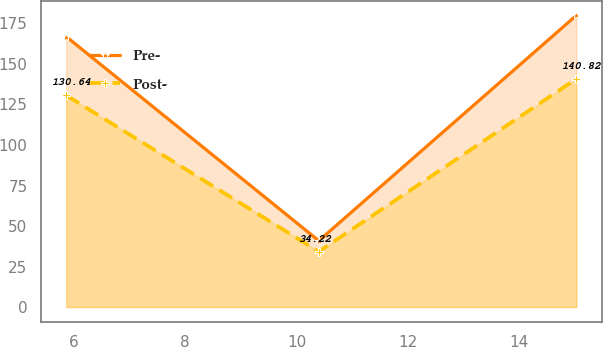<chart> <loc_0><loc_0><loc_500><loc_500><line_chart><ecel><fcel>Pre-<fcel>Post-<nl><fcel>5.86<fcel>166.87<fcel>130.64<nl><fcel>10.4<fcel>40.91<fcel>34.22<nl><fcel>15.03<fcel>179.97<fcel>140.82<nl></chart> 